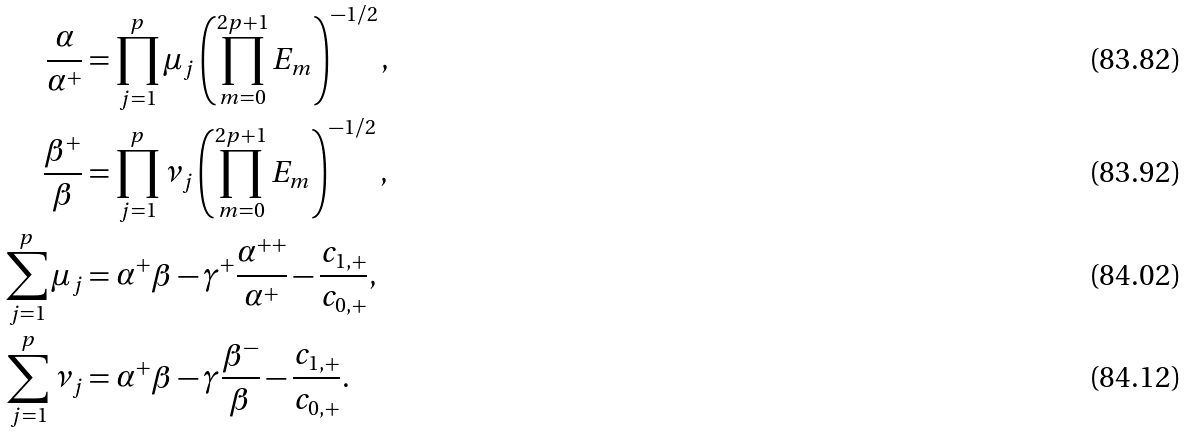<formula> <loc_0><loc_0><loc_500><loc_500>\frac { \alpha } { \alpha ^ { + } } & = \prod _ { j = 1 } ^ { p } \mu _ { j } \left ( \prod _ { m = 0 } ^ { 2 p + 1 } E _ { m } \right ) ^ { - 1 / 2 } , \\ \frac { \beta ^ { + } } { \beta } & = \prod _ { j = 1 } ^ { p } \nu _ { j } \left ( \prod _ { m = 0 } ^ { 2 p + 1 } E _ { m } \right ) ^ { - 1 / 2 } , \\ \sum _ { j = 1 } ^ { p } \mu _ { j } & = \alpha ^ { + } \beta - \gamma ^ { + } \frac { \alpha ^ { + + } } { \alpha ^ { + } } - \frac { c _ { 1 , + } } { c _ { 0 , + } } , \\ \sum _ { j = 1 } ^ { p } \nu _ { j } & = \alpha ^ { + } \beta - \gamma \frac { \beta ^ { - } } { \beta } - \frac { c _ { 1 , + } } { c _ { 0 , + } } .</formula> 